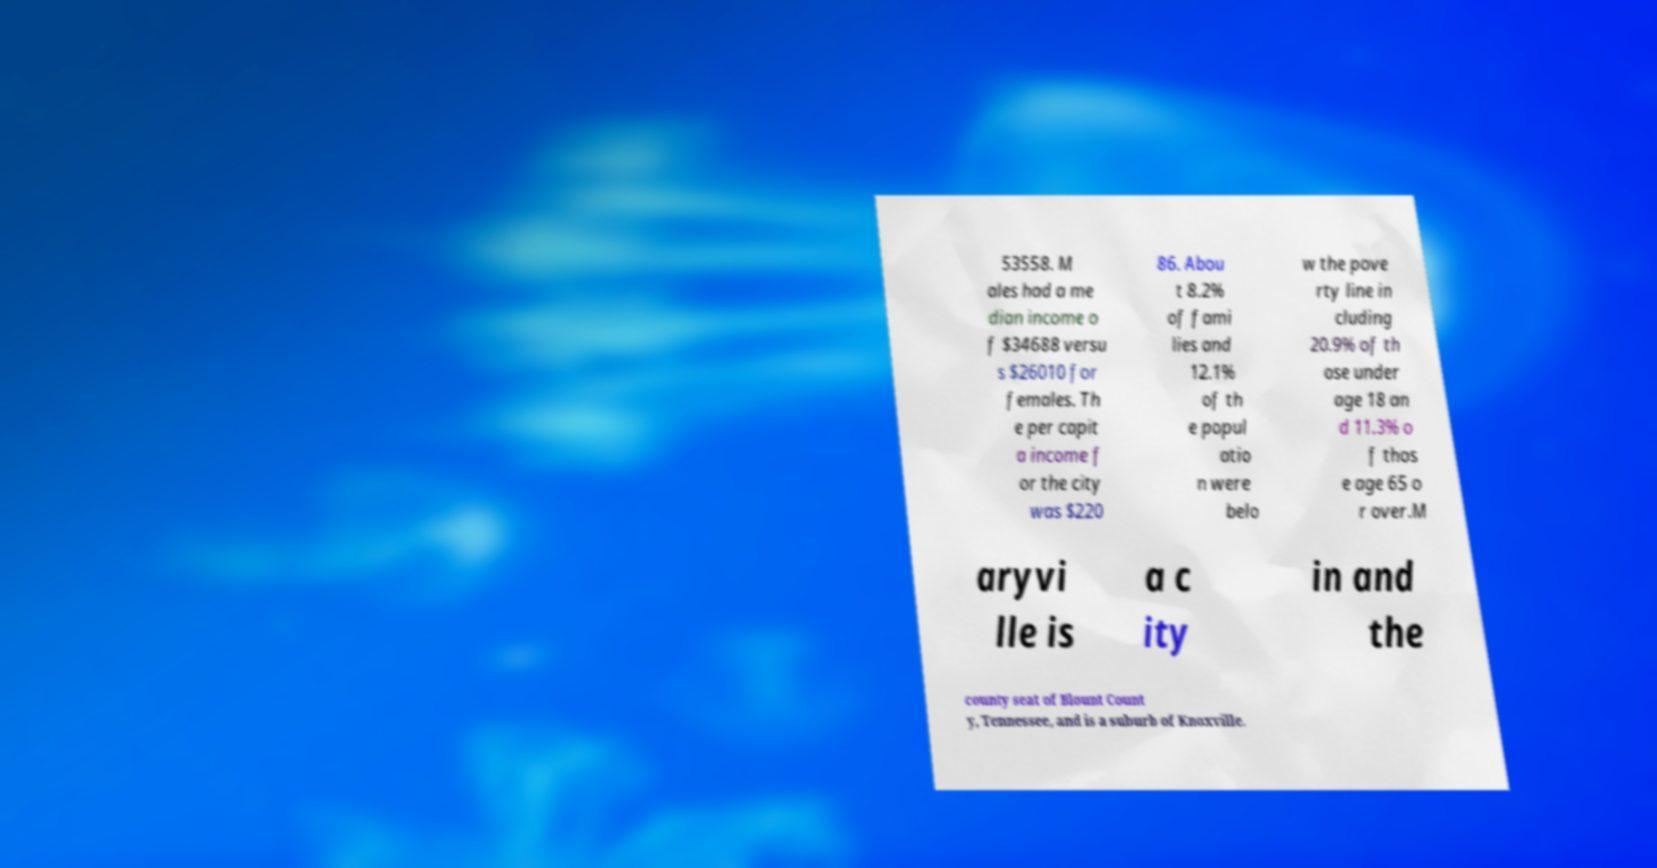Please read and relay the text visible in this image. What does it say? 53558. M ales had a me dian income o f $34688 versu s $26010 for females. Th e per capit a income f or the city was $220 86. Abou t 8.2% of fami lies and 12.1% of th e popul atio n were belo w the pove rty line in cluding 20.9% of th ose under age 18 an d 11.3% o f thos e age 65 o r over.M aryvi lle is a c ity in and the county seat of Blount Count y, Tennessee, and is a suburb of Knoxville. 